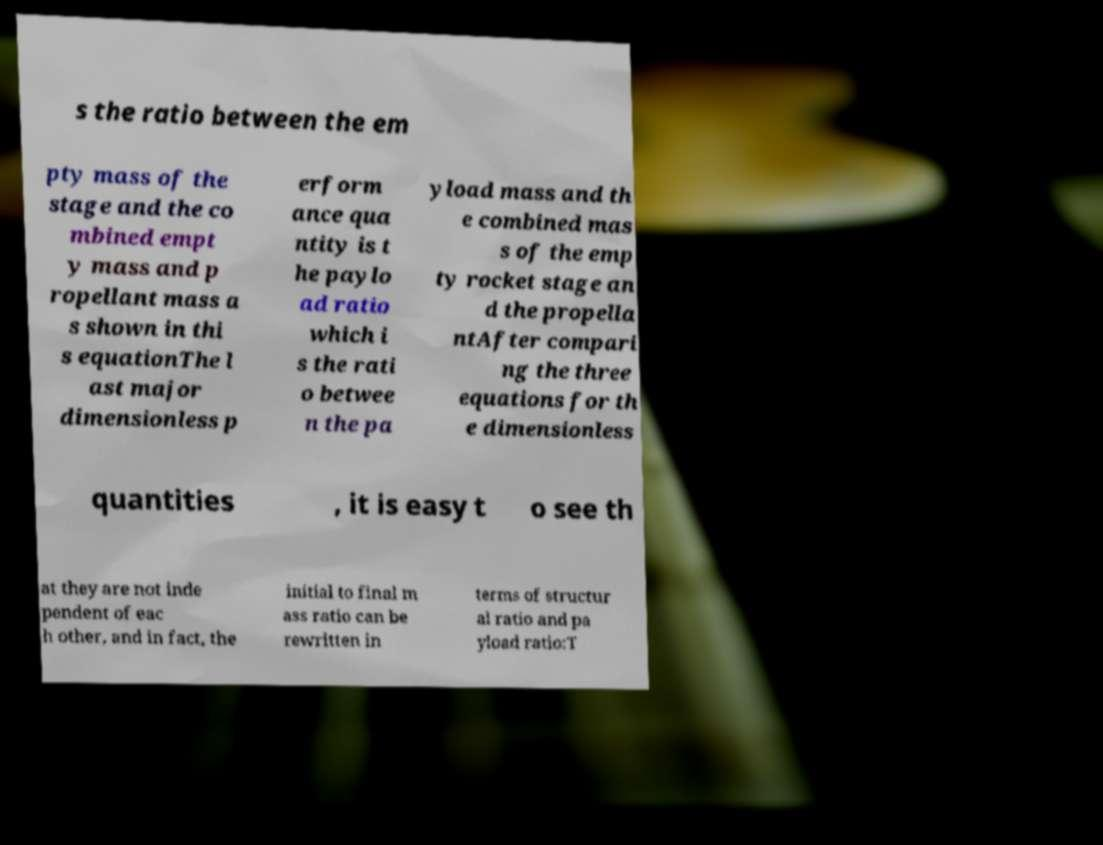I need the written content from this picture converted into text. Can you do that? s the ratio between the em pty mass of the stage and the co mbined empt y mass and p ropellant mass a s shown in thi s equationThe l ast major dimensionless p erform ance qua ntity is t he paylo ad ratio which i s the rati o betwee n the pa yload mass and th e combined mas s of the emp ty rocket stage an d the propella ntAfter compari ng the three equations for th e dimensionless quantities , it is easy t o see th at they are not inde pendent of eac h other, and in fact, the initial to final m ass ratio can be rewritten in terms of structur al ratio and pa yload ratio:T 